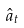<formula> <loc_0><loc_0><loc_500><loc_500>\hat { a } _ { t }</formula> 